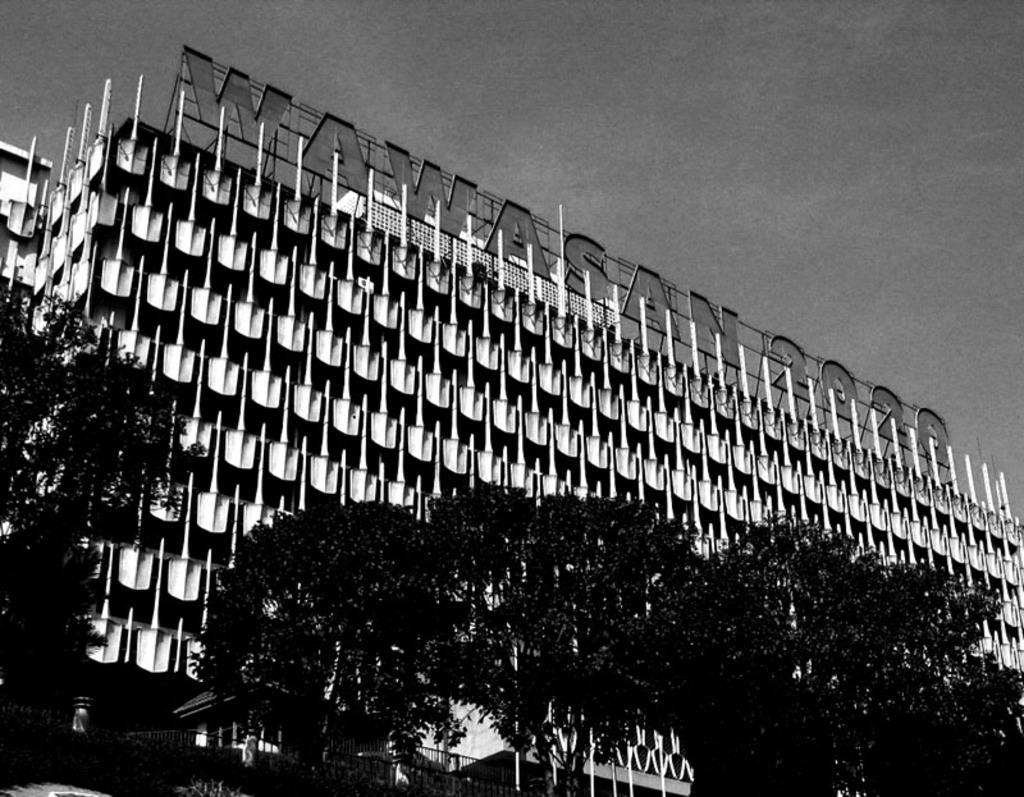What is the color scheme of the image? The image is black and white. What type of natural elements can be seen in the image? There are trees in the image. What type of man-made structures are present in the image? There are buildings in the image. What is visible at the top of the image? The sky is visible at the top of the image. Where is the art coach located in the image? There is no art coach present in the image. What type of cellar can be seen in the image? There is no cellar present in the image. 